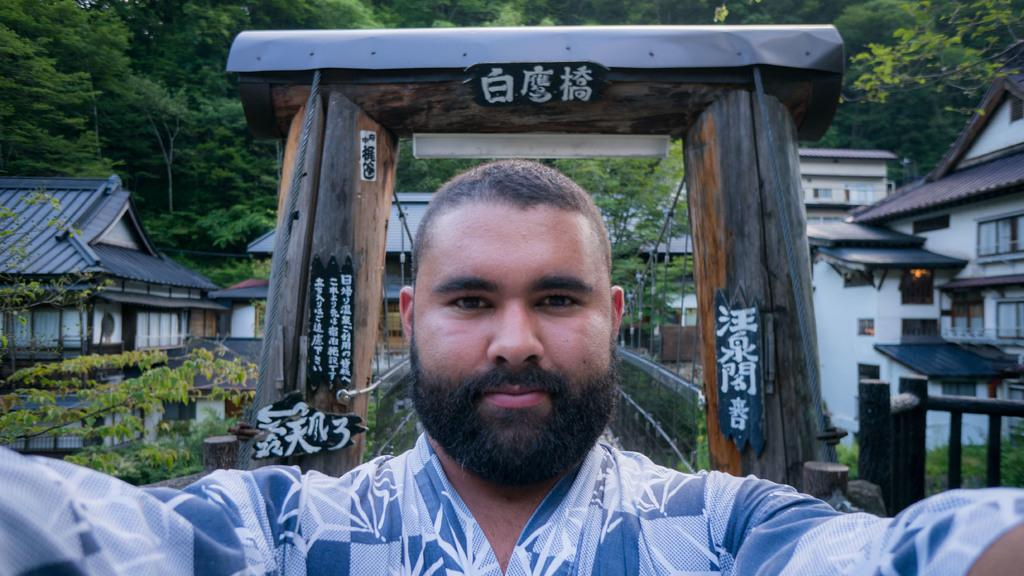Who is present in the image? There is a man in the image. What is the man wearing? The man is wearing a blue shirt. What can be seen in the background of the image? There is an arch made of wood and many buildings in the background. What color is the man's eye in the image? The provided facts do not mention the color of the man's eye, so it cannot be determined from the image. 